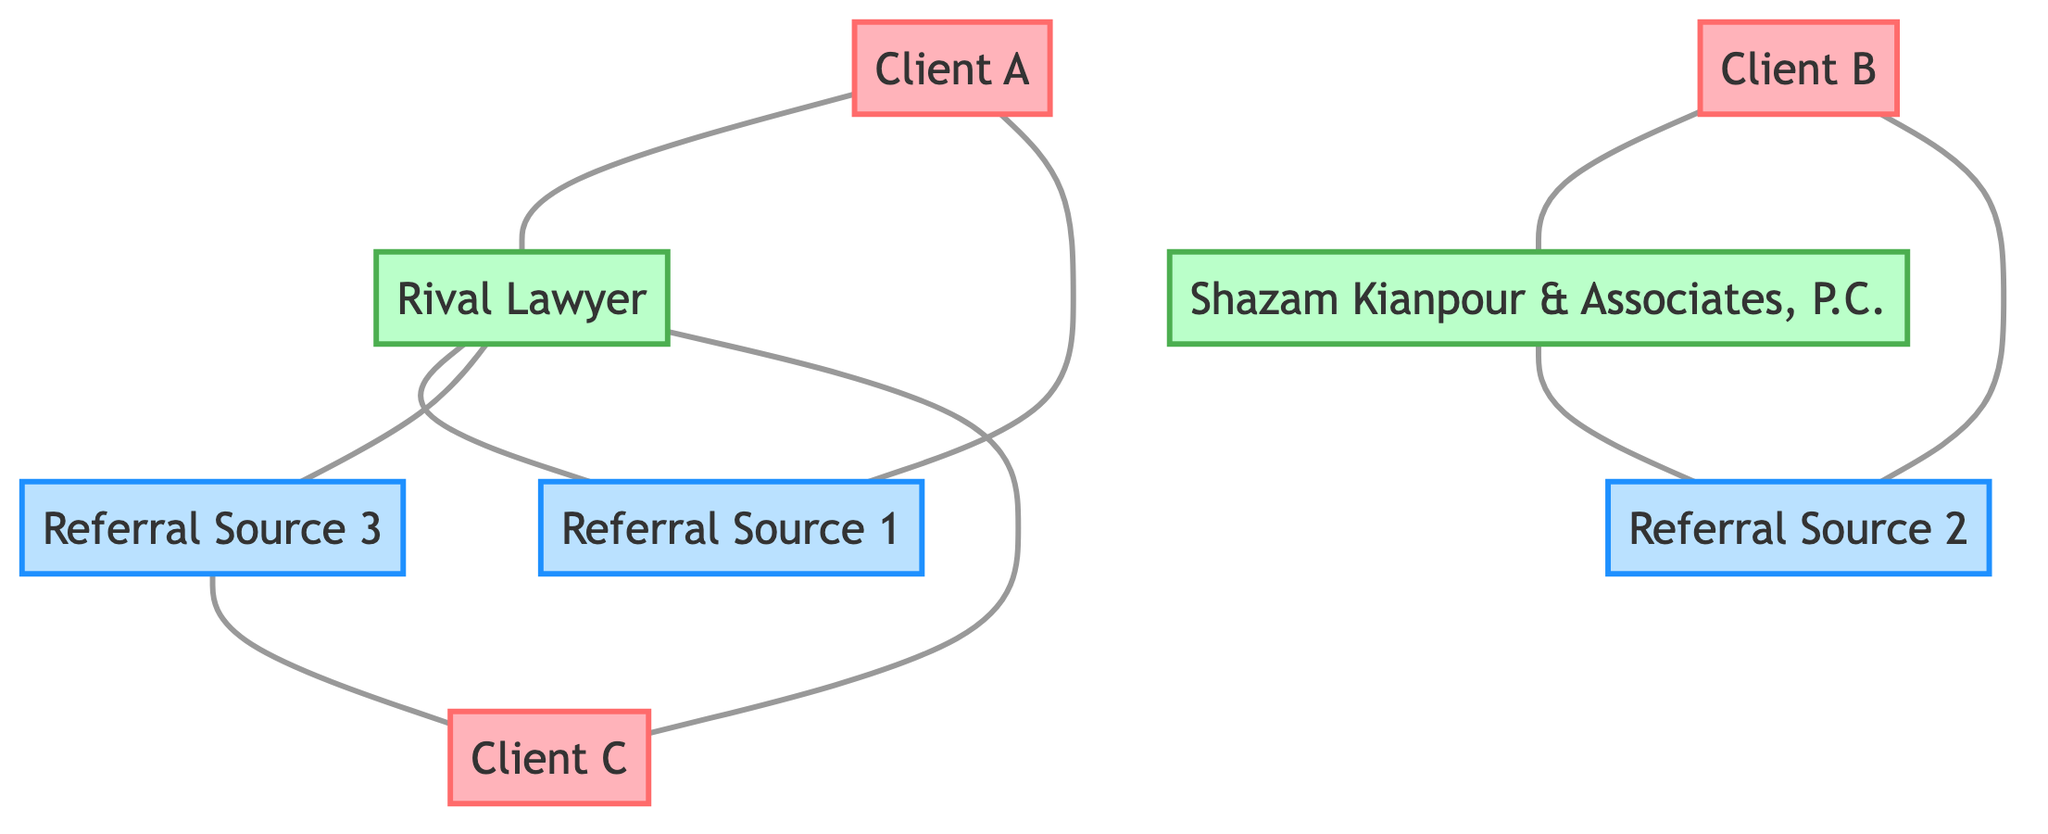What is the total number of nodes in the diagram? The diagram includes the following nodes: Client A, Client B, Client C, Rival Lawyer, Shazam Kianpour & Associates, P.C., Referral Source 1, Referral Source 2, and Referral Source 3. Counting these gives a total of 8 nodes.
Answer: 8 Which client is connected directly to the Rival Lawyer? The diagram shows connections from Client A and Client C to the Rival Lawyer. Therefore, both Client A and Client C are directly connected to the Rival Lawyer, but since we are looking for one, a clear answer is Client A.
Answer: Client A How many edges are connected to the Shazam Kianpour & Associates, P.C.? The Shazam Kianpour & Associates, P.C. is connected by one edge to Referral Source 2. Counting this gives us a total of 1 edge.
Answer: 1 What is the relationship between Client B and Shazam Kianpour & Associates, P.C.? The diagram shows a direct connection (edge) from Client B to Shazam Kianpour & Associates, P.C., indicating that they are connected directly.
Answer: Direct connection Which referral source has the most connections? Examining the connections: Referral Source 1 is connected to Client A and Rival Lawyer; Referral Source 2 is connected to Client B and Shazam Lawyers; Referral Source 3 is connected to Client C and Rival Lawyer. Both Referral Source 1 and Referral Source 3 have 2 connections, while Referral Source 2 has 2 as well, meaning the count is equal.
Answer: Referral Source 1 and Referral Source 3 What is the total number of edges in the diagram? By examining the connections, we find the edges: Client 1 to Rival Lawyer (1); Client 2 to Shazam Lawyers (2); Client 3 to Rival Lawyer (3); Rival Lawyer to Referral 1 (4); Rival Lawyer to Referral 3 (5); Shazam Lawyers to Referral 2 (6); Referral 1 to Client 1 (7); Referral 2 to Client 2 (8); Referral 3 to Client 3 (9). This totals 9 edges.
Answer: 9 Which client is referred by Referral Source 3? The diagram indicates that Referral Source 3 is connected directly to Client C, establishing that Referral Source 3 is the referrer for Client C.
Answer: Client C 